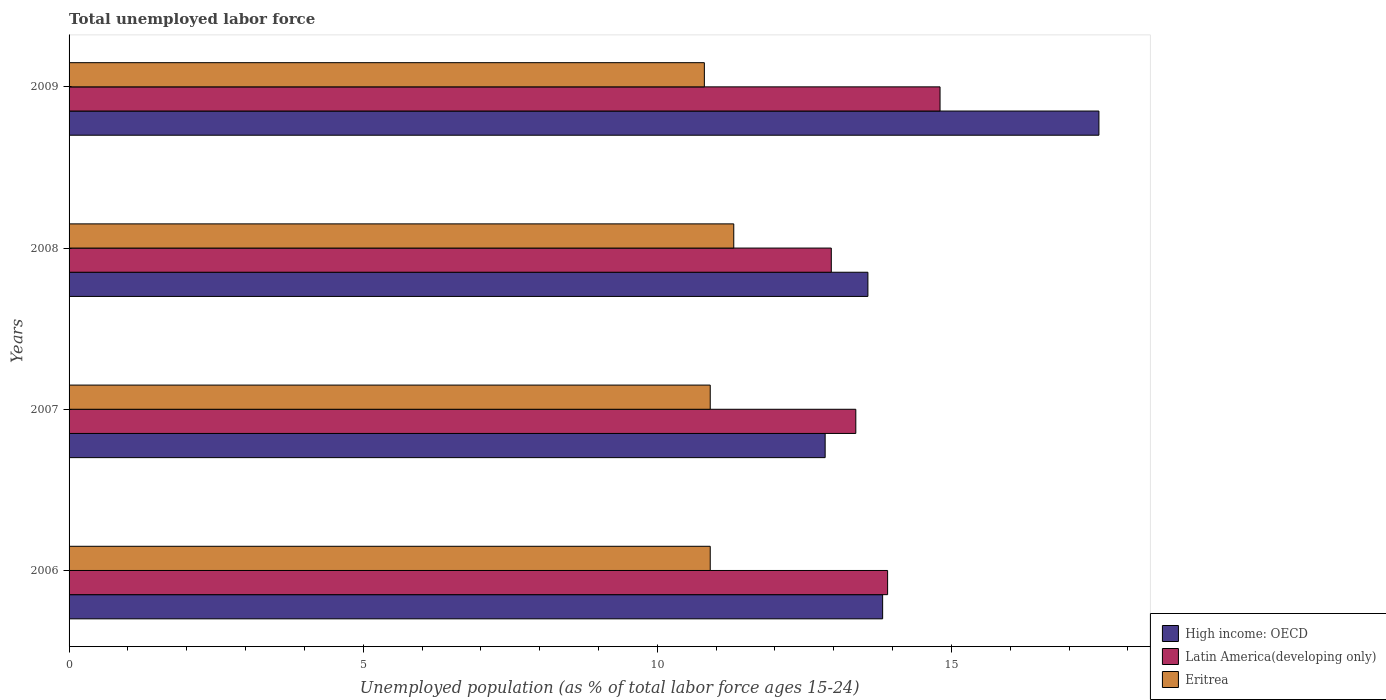How many different coloured bars are there?
Keep it short and to the point. 3. Are the number of bars on each tick of the Y-axis equal?
Your response must be concise. Yes. How many bars are there on the 1st tick from the top?
Your answer should be very brief. 3. What is the label of the 2nd group of bars from the top?
Give a very brief answer. 2008. In how many cases, is the number of bars for a given year not equal to the number of legend labels?
Ensure brevity in your answer.  0. What is the percentage of unemployed population in in High income: OECD in 2009?
Your answer should be compact. 17.51. Across all years, what is the maximum percentage of unemployed population in in High income: OECD?
Keep it short and to the point. 17.51. Across all years, what is the minimum percentage of unemployed population in in High income: OECD?
Ensure brevity in your answer.  12.85. What is the total percentage of unemployed population in in Latin America(developing only) in the graph?
Offer a very short reply. 55.06. What is the difference between the percentage of unemployed population in in High income: OECD in 2007 and that in 2009?
Offer a very short reply. -4.65. What is the difference between the percentage of unemployed population in in High income: OECD in 2006 and the percentage of unemployed population in in Latin America(developing only) in 2007?
Ensure brevity in your answer.  0.46. What is the average percentage of unemployed population in in Latin America(developing only) per year?
Give a very brief answer. 13.76. In the year 2008, what is the difference between the percentage of unemployed population in in High income: OECD and percentage of unemployed population in in Eritrea?
Make the answer very short. 2.28. In how many years, is the percentage of unemployed population in in Eritrea greater than 8 %?
Your response must be concise. 4. What is the ratio of the percentage of unemployed population in in Eritrea in 2007 to that in 2009?
Offer a terse response. 1.01. What is the difference between the highest and the second highest percentage of unemployed population in in Latin America(developing only)?
Keep it short and to the point. 0.89. What does the 3rd bar from the top in 2009 represents?
Your answer should be compact. High income: OECD. What does the 2nd bar from the bottom in 2007 represents?
Your answer should be compact. Latin America(developing only). Is it the case that in every year, the sum of the percentage of unemployed population in in Latin America(developing only) and percentage of unemployed population in in High income: OECD is greater than the percentage of unemployed population in in Eritrea?
Your response must be concise. Yes. How many bars are there?
Provide a short and direct response. 12. Are the values on the major ticks of X-axis written in scientific E-notation?
Offer a very short reply. No. Does the graph contain any zero values?
Make the answer very short. No. Where does the legend appear in the graph?
Your answer should be compact. Bottom right. How are the legend labels stacked?
Keep it short and to the point. Vertical. What is the title of the graph?
Keep it short and to the point. Total unemployed labor force. Does "New Zealand" appear as one of the legend labels in the graph?
Offer a very short reply. No. What is the label or title of the X-axis?
Provide a succinct answer. Unemployed population (as % of total labor force ages 15-24). What is the label or title of the Y-axis?
Provide a succinct answer. Years. What is the Unemployed population (as % of total labor force ages 15-24) of High income: OECD in 2006?
Your response must be concise. 13.83. What is the Unemployed population (as % of total labor force ages 15-24) of Latin America(developing only) in 2006?
Provide a short and direct response. 13.92. What is the Unemployed population (as % of total labor force ages 15-24) of Eritrea in 2006?
Offer a terse response. 10.9. What is the Unemployed population (as % of total labor force ages 15-24) in High income: OECD in 2007?
Offer a terse response. 12.85. What is the Unemployed population (as % of total labor force ages 15-24) in Latin America(developing only) in 2007?
Make the answer very short. 13.37. What is the Unemployed population (as % of total labor force ages 15-24) in Eritrea in 2007?
Keep it short and to the point. 10.9. What is the Unemployed population (as % of total labor force ages 15-24) of High income: OECD in 2008?
Offer a very short reply. 13.58. What is the Unemployed population (as % of total labor force ages 15-24) in Latin America(developing only) in 2008?
Offer a very short reply. 12.96. What is the Unemployed population (as % of total labor force ages 15-24) in Eritrea in 2008?
Provide a succinct answer. 11.3. What is the Unemployed population (as % of total labor force ages 15-24) of High income: OECD in 2009?
Your response must be concise. 17.51. What is the Unemployed population (as % of total labor force ages 15-24) of Latin America(developing only) in 2009?
Make the answer very short. 14.81. What is the Unemployed population (as % of total labor force ages 15-24) in Eritrea in 2009?
Your response must be concise. 10.8. Across all years, what is the maximum Unemployed population (as % of total labor force ages 15-24) of High income: OECD?
Make the answer very short. 17.51. Across all years, what is the maximum Unemployed population (as % of total labor force ages 15-24) in Latin America(developing only)?
Your answer should be compact. 14.81. Across all years, what is the maximum Unemployed population (as % of total labor force ages 15-24) of Eritrea?
Give a very brief answer. 11.3. Across all years, what is the minimum Unemployed population (as % of total labor force ages 15-24) of High income: OECD?
Offer a terse response. 12.85. Across all years, what is the minimum Unemployed population (as % of total labor force ages 15-24) in Latin America(developing only)?
Provide a short and direct response. 12.96. Across all years, what is the minimum Unemployed population (as % of total labor force ages 15-24) of Eritrea?
Offer a terse response. 10.8. What is the total Unemployed population (as % of total labor force ages 15-24) of High income: OECD in the graph?
Your answer should be very brief. 57.77. What is the total Unemployed population (as % of total labor force ages 15-24) in Latin America(developing only) in the graph?
Give a very brief answer. 55.06. What is the total Unemployed population (as % of total labor force ages 15-24) of Eritrea in the graph?
Your answer should be compact. 43.9. What is the difference between the Unemployed population (as % of total labor force ages 15-24) in High income: OECD in 2006 and that in 2007?
Ensure brevity in your answer.  0.98. What is the difference between the Unemployed population (as % of total labor force ages 15-24) of Latin America(developing only) in 2006 and that in 2007?
Ensure brevity in your answer.  0.54. What is the difference between the Unemployed population (as % of total labor force ages 15-24) in High income: OECD in 2006 and that in 2008?
Make the answer very short. 0.25. What is the difference between the Unemployed population (as % of total labor force ages 15-24) of Latin America(developing only) in 2006 and that in 2008?
Make the answer very short. 0.96. What is the difference between the Unemployed population (as % of total labor force ages 15-24) of High income: OECD in 2006 and that in 2009?
Give a very brief answer. -3.68. What is the difference between the Unemployed population (as % of total labor force ages 15-24) of Latin America(developing only) in 2006 and that in 2009?
Your answer should be very brief. -0.89. What is the difference between the Unemployed population (as % of total labor force ages 15-24) of Eritrea in 2006 and that in 2009?
Ensure brevity in your answer.  0.1. What is the difference between the Unemployed population (as % of total labor force ages 15-24) of High income: OECD in 2007 and that in 2008?
Provide a short and direct response. -0.73. What is the difference between the Unemployed population (as % of total labor force ages 15-24) of Latin America(developing only) in 2007 and that in 2008?
Give a very brief answer. 0.42. What is the difference between the Unemployed population (as % of total labor force ages 15-24) in Eritrea in 2007 and that in 2008?
Offer a very short reply. -0.4. What is the difference between the Unemployed population (as % of total labor force ages 15-24) of High income: OECD in 2007 and that in 2009?
Offer a terse response. -4.65. What is the difference between the Unemployed population (as % of total labor force ages 15-24) in Latin America(developing only) in 2007 and that in 2009?
Offer a very short reply. -1.43. What is the difference between the Unemployed population (as % of total labor force ages 15-24) of High income: OECD in 2008 and that in 2009?
Provide a succinct answer. -3.93. What is the difference between the Unemployed population (as % of total labor force ages 15-24) in Latin America(developing only) in 2008 and that in 2009?
Offer a terse response. -1.85. What is the difference between the Unemployed population (as % of total labor force ages 15-24) in Eritrea in 2008 and that in 2009?
Keep it short and to the point. 0.5. What is the difference between the Unemployed population (as % of total labor force ages 15-24) in High income: OECD in 2006 and the Unemployed population (as % of total labor force ages 15-24) in Latin America(developing only) in 2007?
Provide a succinct answer. 0.46. What is the difference between the Unemployed population (as % of total labor force ages 15-24) of High income: OECD in 2006 and the Unemployed population (as % of total labor force ages 15-24) of Eritrea in 2007?
Ensure brevity in your answer.  2.93. What is the difference between the Unemployed population (as % of total labor force ages 15-24) of Latin America(developing only) in 2006 and the Unemployed population (as % of total labor force ages 15-24) of Eritrea in 2007?
Your answer should be very brief. 3.02. What is the difference between the Unemployed population (as % of total labor force ages 15-24) of High income: OECD in 2006 and the Unemployed population (as % of total labor force ages 15-24) of Latin America(developing only) in 2008?
Make the answer very short. 0.87. What is the difference between the Unemployed population (as % of total labor force ages 15-24) in High income: OECD in 2006 and the Unemployed population (as % of total labor force ages 15-24) in Eritrea in 2008?
Give a very brief answer. 2.53. What is the difference between the Unemployed population (as % of total labor force ages 15-24) of Latin America(developing only) in 2006 and the Unemployed population (as % of total labor force ages 15-24) of Eritrea in 2008?
Provide a short and direct response. 2.62. What is the difference between the Unemployed population (as % of total labor force ages 15-24) in High income: OECD in 2006 and the Unemployed population (as % of total labor force ages 15-24) in Latin America(developing only) in 2009?
Provide a short and direct response. -0.98. What is the difference between the Unemployed population (as % of total labor force ages 15-24) of High income: OECD in 2006 and the Unemployed population (as % of total labor force ages 15-24) of Eritrea in 2009?
Your answer should be very brief. 3.03. What is the difference between the Unemployed population (as % of total labor force ages 15-24) of Latin America(developing only) in 2006 and the Unemployed population (as % of total labor force ages 15-24) of Eritrea in 2009?
Your answer should be compact. 3.12. What is the difference between the Unemployed population (as % of total labor force ages 15-24) of High income: OECD in 2007 and the Unemployed population (as % of total labor force ages 15-24) of Latin America(developing only) in 2008?
Your response must be concise. -0.1. What is the difference between the Unemployed population (as % of total labor force ages 15-24) in High income: OECD in 2007 and the Unemployed population (as % of total labor force ages 15-24) in Eritrea in 2008?
Keep it short and to the point. 1.55. What is the difference between the Unemployed population (as % of total labor force ages 15-24) in Latin America(developing only) in 2007 and the Unemployed population (as % of total labor force ages 15-24) in Eritrea in 2008?
Give a very brief answer. 2.07. What is the difference between the Unemployed population (as % of total labor force ages 15-24) in High income: OECD in 2007 and the Unemployed population (as % of total labor force ages 15-24) in Latin America(developing only) in 2009?
Provide a short and direct response. -1.95. What is the difference between the Unemployed population (as % of total labor force ages 15-24) of High income: OECD in 2007 and the Unemployed population (as % of total labor force ages 15-24) of Eritrea in 2009?
Make the answer very short. 2.05. What is the difference between the Unemployed population (as % of total labor force ages 15-24) in Latin America(developing only) in 2007 and the Unemployed population (as % of total labor force ages 15-24) in Eritrea in 2009?
Provide a succinct answer. 2.57. What is the difference between the Unemployed population (as % of total labor force ages 15-24) in High income: OECD in 2008 and the Unemployed population (as % of total labor force ages 15-24) in Latin America(developing only) in 2009?
Provide a succinct answer. -1.23. What is the difference between the Unemployed population (as % of total labor force ages 15-24) in High income: OECD in 2008 and the Unemployed population (as % of total labor force ages 15-24) in Eritrea in 2009?
Your answer should be compact. 2.78. What is the difference between the Unemployed population (as % of total labor force ages 15-24) in Latin America(developing only) in 2008 and the Unemployed population (as % of total labor force ages 15-24) in Eritrea in 2009?
Provide a short and direct response. 2.16. What is the average Unemployed population (as % of total labor force ages 15-24) in High income: OECD per year?
Offer a very short reply. 14.44. What is the average Unemployed population (as % of total labor force ages 15-24) of Latin America(developing only) per year?
Your answer should be compact. 13.76. What is the average Unemployed population (as % of total labor force ages 15-24) of Eritrea per year?
Provide a short and direct response. 10.97. In the year 2006, what is the difference between the Unemployed population (as % of total labor force ages 15-24) in High income: OECD and Unemployed population (as % of total labor force ages 15-24) in Latin America(developing only)?
Provide a short and direct response. -0.08. In the year 2006, what is the difference between the Unemployed population (as % of total labor force ages 15-24) in High income: OECD and Unemployed population (as % of total labor force ages 15-24) in Eritrea?
Provide a succinct answer. 2.93. In the year 2006, what is the difference between the Unemployed population (as % of total labor force ages 15-24) in Latin America(developing only) and Unemployed population (as % of total labor force ages 15-24) in Eritrea?
Make the answer very short. 3.02. In the year 2007, what is the difference between the Unemployed population (as % of total labor force ages 15-24) of High income: OECD and Unemployed population (as % of total labor force ages 15-24) of Latin America(developing only)?
Keep it short and to the point. -0.52. In the year 2007, what is the difference between the Unemployed population (as % of total labor force ages 15-24) of High income: OECD and Unemployed population (as % of total labor force ages 15-24) of Eritrea?
Your response must be concise. 1.95. In the year 2007, what is the difference between the Unemployed population (as % of total labor force ages 15-24) in Latin America(developing only) and Unemployed population (as % of total labor force ages 15-24) in Eritrea?
Your answer should be compact. 2.47. In the year 2008, what is the difference between the Unemployed population (as % of total labor force ages 15-24) in High income: OECD and Unemployed population (as % of total labor force ages 15-24) in Latin America(developing only)?
Provide a short and direct response. 0.62. In the year 2008, what is the difference between the Unemployed population (as % of total labor force ages 15-24) in High income: OECD and Unemployed population (as % of total labor force ages 15-24) in Eritrea?
Make the answer very short. 2.28. In the year 2008, what is the difference between the Unemployed population (as % of total labor force ages 15-24) in Latin America(developing only) and Unemployed population (as % of total labor force ages 15-24) in Eritrea?
Your answer should be very brief. 1.66. In the year 2009, what is the difference between the Unemployed population (as % of total labor force ages 15-24) in High income: OECD and Unemployed population (as % of total labor force ages 15-24) in Latin America(developing only)?
Your answer should be compact. 2.7. In the year 2009, what is the difference between the Unemployed population (as % of total labor force ages 15-24) of High income: OECD and Unemployed population (as % of total labor force ages 15-24) of Eritrea?
Provide a succinct answer. 6.71. In the year 2009, what is the difference between the Unemployed population (as % of total labor force ages 15-24) in Latin America(developing only) and Unemployed population (as % of total labor force ages 15-24) in Eritrea?
Provide a short and direct response. 4.01. What is the ratio of the Unemployed population (as % of total labor force ages 15-24) of High income: OECD in 2006 to that in 2007?
Provide a short and direct response. 1.08. What is the ratio of the Unemployed population (as % of total labor force ages 15-24) in Latin America(developing only) in 2006 to that in 2007?
Ensure brevity in your answer.  1.04. What is the ratio of the Unemployed population (as % of total labor force ages 15-24) of High income: OECD in 2006 to that in 2008?
Keep it short and to the point. 1.02. What is the ratio of the Unemployed population (as % of total labor force ages 15-24) in Latin America(developing only) in 2006 to that in 2008?
Your answer should be compact. 1.07. What is the ratio of the Unemployed population (as % of total labor force ages 15-24) in Eritrea in 2006 to that in 2008?
Offer a terse response. 0.96. What is the ratio of the Unemployed population (as % of total labor force ages 15-24) of High income: OECD in 2006 to that in 2009?
Offer a terse response. 0.79. What is the ratio of the Unemployed population (as % of total labor force ages 15-24) in Latin America(developing only) in 2006 to that in 2009?
Provide a succinct answer. 0.94. What is the ratio of the Unemployed population (as % of total labor force ages 15-24) in Eritrea in 2006 to that in 2009?
Your answer should be compact. 1.01. What is the ratio of the Unemployed population (as % of total labor force ages 15-24) in High income: OECD in 2007 to that in 2008?
Your answer should be compact. 0.95. What is the ratio of the Unemployed population (as % of total labor force ages 15-24) of Latin America(developing only) in 2007 to that in 2008?
Provide a short and direct response. 1.03. What is the ratio of the Unemployed population (as % of total labor force ages 15-24) of Eritrea in 2007 to that in 2008?
Make the answer very short. 0.96. What is the ratio of the Unemployed population (as % of total labor force ages 15-24) of High income: OECD in 2007 to that in 2009?
Offer a terse response. 0.73. What is the ratio of the Unemployed population (as % of total labor force ages 15-24) in Latin America(developing only) in 2007 to that in 2009?
Give a very brief answer. 0.9. What is the ratio of the Unemployed population (as % of total labor force ages 15-24) in Eritrea in 2007 to that in 2009?
Keep it short and to the point. 1.01. What is the ratio of the Unemployed population (as % of total labor force ages 15-24) in High income: OECD in 2008 to that in 2009?
Your answer should be compact. 0.78. What is the ratio of the Unemployed population (as % of total labor force ages 15-24) in Latin America(developing only) in 2008 to that in 2009?
Make the answer very short. 0.88. What is the ratio of the Unemployed population (as % of total labor force ages 15-24) of Eritrea in 2008 to that in 2009?
Keep it short and to the point. 1.05. What is the difference between the highest and the second highest Unemployed population (as % of total labor force ages 15-24) in High income: OECD?
Offer a very short reply. 3.68. What is the difference between the highest and the second highest Unemployed population (as % of total labor force ages 15-24) in Latin America(developing only)?
Offer a terse response. 0.89. What is the difference between the highest and the second highest Unemployed population (as % of total labor force ages 15-24) in Eritrea?
Ensure brevity in your answer.  0.4. What is the difference between the highest and the lowest Unemployed population (as % of total labor force ages 15-24) of High income: OECD?
Keep it short and to the point. 4.65. What is the difference between the highest and the lowest Unemployed population (as % of total labor force ages 15-24) of Latin America(developing only)?
Give a very brief answer. 1.85. What is the difference between the highest and the lowest Unemployed population (as % of total labor force ages 15-24) of Eritrea?
Ensure brevity in your answer.  0.5. 